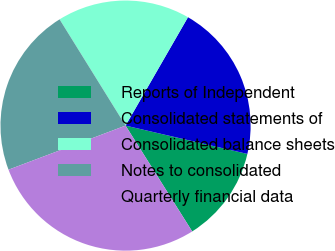Convert chart to OTSL. <chart><loc_0><loc_0><loc_500><loc_500><pie_chart><fcel>Reports of Independent<fcel>Consolidated statements of<fcel>Consolidated balance sheets<fcel>Notes to consolidated<fcel>Quarterly financial data<nl><fcel>12.42%<fcel>20.32%<fcel>17.16%<fcel>21.89%<fcel>28.21%<nl></chart> 